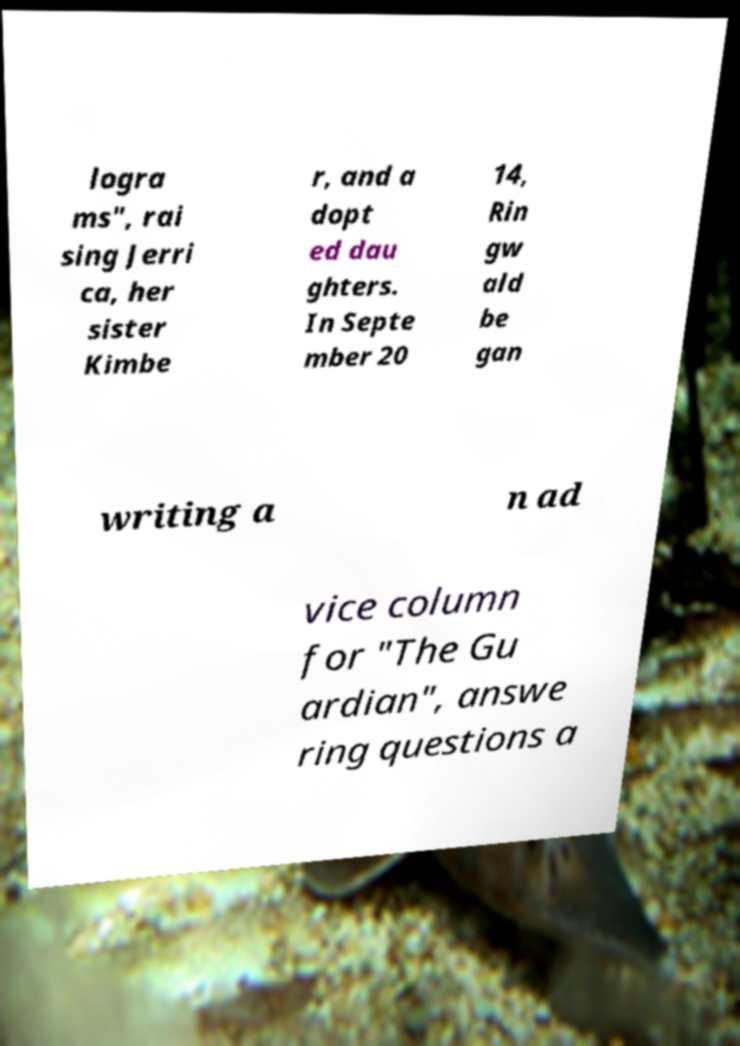Can you read and provide the text displayed in the image?This photo seems to have some interesting text. Can you extract and type it out for me? logra ms", rai sing Jerri ca, her sister Kimbe r, and a dopt ed dau ghters. In Septe mber 20 14, Rin gw ald be gan writing a n ad vice column for "The Gu ardian", answe ring questions a 